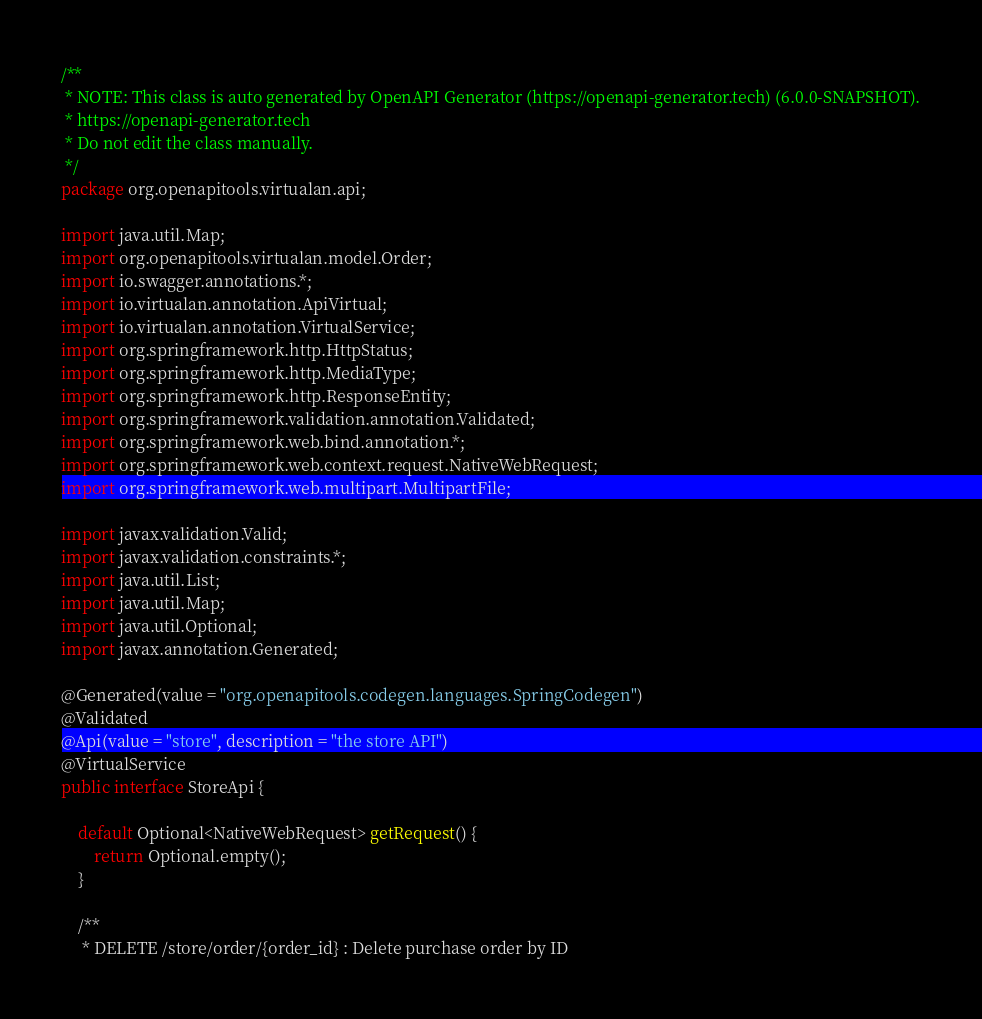Convert code to text. <code><loc_0><loc_0><loc_500><loc_500><_Java_>/**
 * NOTE: This class is auto generated by OpenAPI Generator (https://openapi-generator.tech) (6.0.0-SNAPSHOT).
 * https://openapi-generator.tech
 * Do not edit the class manually.
 */
package org.openapitools.virtualan.api;

import java.util.Map;
import org.openapitools.virtualan.model.Order;
import io.swagger.annotations.*;
import io.virtualan.annotation.ApiVirtual;
import io.virtualan.annotation.VirtualService;
import org.springframework.http.HttpStatus;
import org.springframework.http.MediaType;
import org.springframework.http.ResponseEntity;
import org.springframework.validation.annotation.Validated;
import org.springframework.web.bind.annotation.*;
import org.springframework.web.context.request.NativeWebRequest;
import org.springframework.web.multipart.MultipartFile;

import javax.validation.Valid;
import javax.validation.constraints.*;
import java.util.List;
import java.util.Map;
import java.util.Optional;
import javax.annotation.Generated;

@Generated(value = "org.openapitools.codegen.languages.SpringCodegen")
@Validated
@Api(value = "store", description = "the store API")
@VirtualService
public interface StoreApi {

    default Optional<NativeWebRequest> getRequest() {
        return Optional.empty();
    }

    /**
     * DELETE /store/order/{order_id} : Delete purchase order by ID</code> 